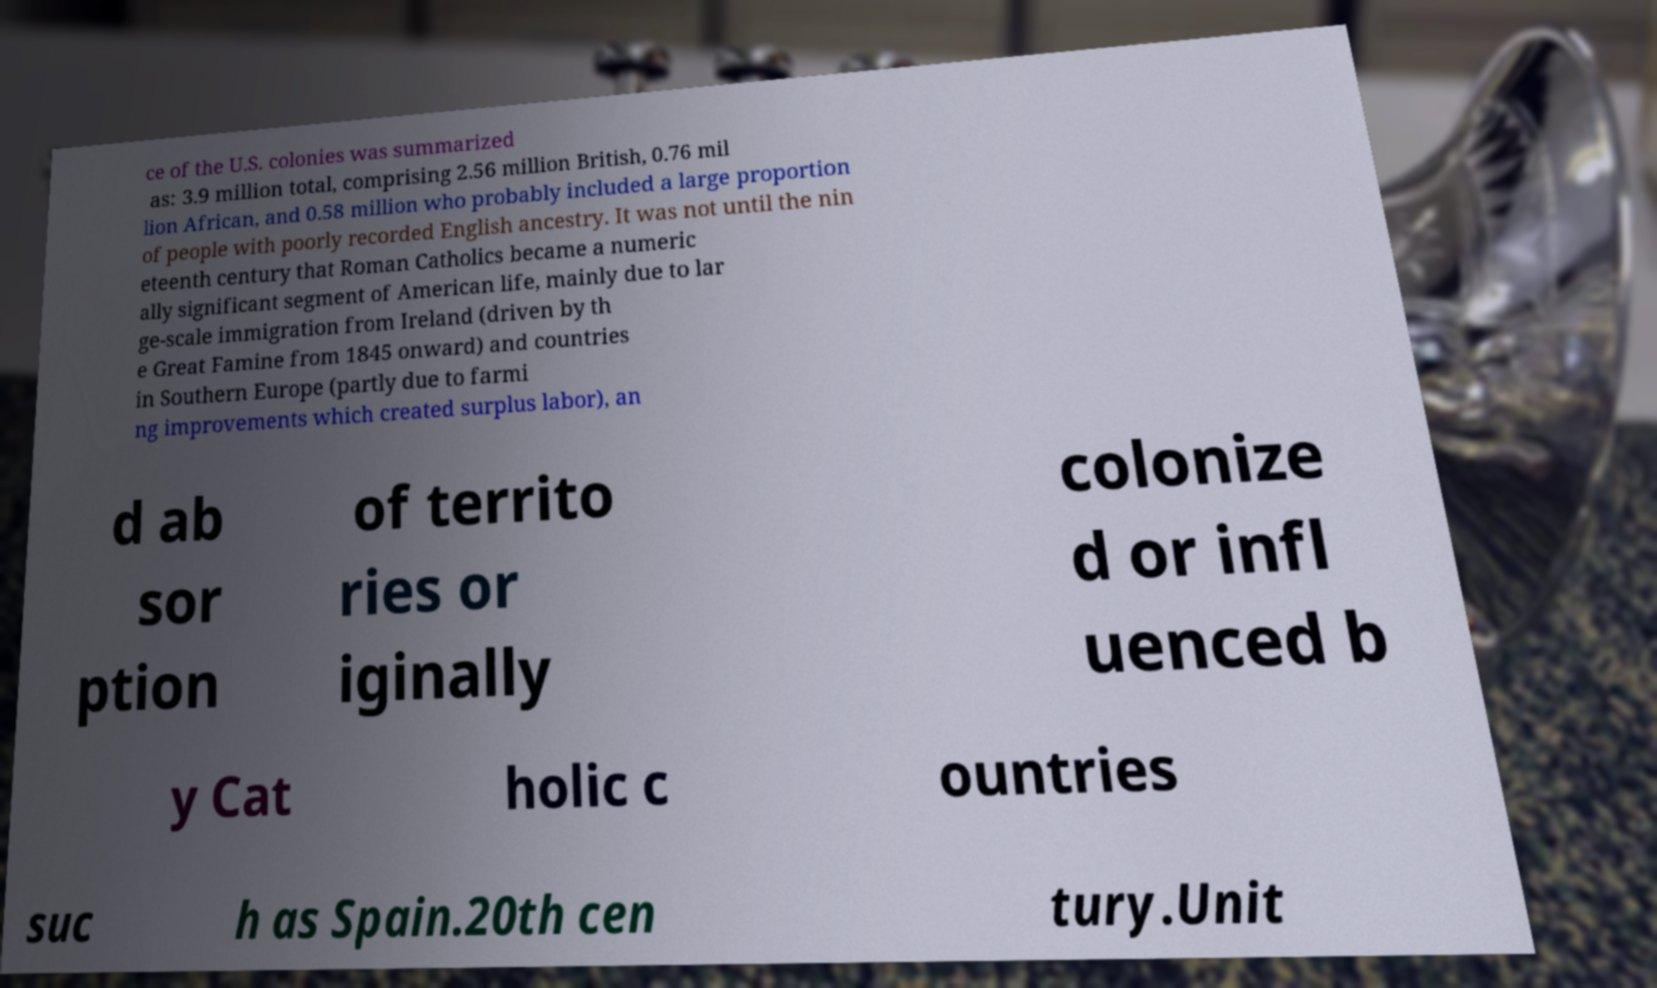There's text embedded in this image that I need extracted. Can you transcribe it verbatim? ce of the U.S. colonies was summarized as: 3.9 million total, comprising 2.56 million British, 0.76 mil lion African, and 0.58 million who probably included a large proportion of people with poorly recorded English ancestry. It was not until the nin eteenth century that Roman Catholics became a numeric ally significant segment of American life, mainly due to lar ge-scale immigration from Ireland (driven by th e Great Famine from 1845 onward) and countries in Southern Europe (partly due to farmi ng improvements which created surplus labor), an d ab sor ption of territo ries or iginally colonize d or infl uenced b y Cat holic c ountries suc h as Spain.20th cen tury.Unit 